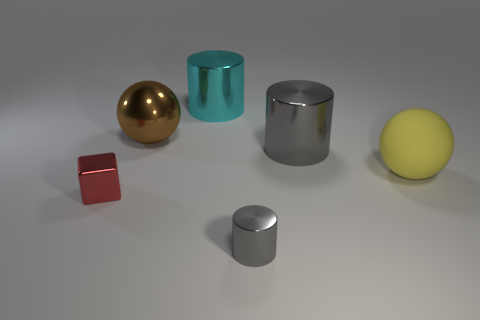Subtract all big shiny cylinders. How many cylinders are left? 1 Add 2 spheres. How many objects exist? 8 Subtract all cyan cylinders. How many cylinders are left? 2 Subtract all blocks. How many objects are left? 5 Subtract 1 cylinders. How many cylinders are left? 2 Subtract all yellow cylinders. How many brown balls are left? 1 Subtract all large cyan metal things. Subtract all gray metallic things. How many objects are left? 3 Add 4 red metallic objects. How many red metallic objects are left? 5 Add 2 big blue matte cylinders. How many big blue matte cylinders exist? 2 Subtract 0 purple spheres. How many objects are left? 6 